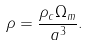Convert formula to latex. <formula><loc_0><loc_0><loc_500><loc_500>\rho = { \frac { \rho _ { c } \Omega _ { m } } { a ^ { 3 } } } .</formula> 